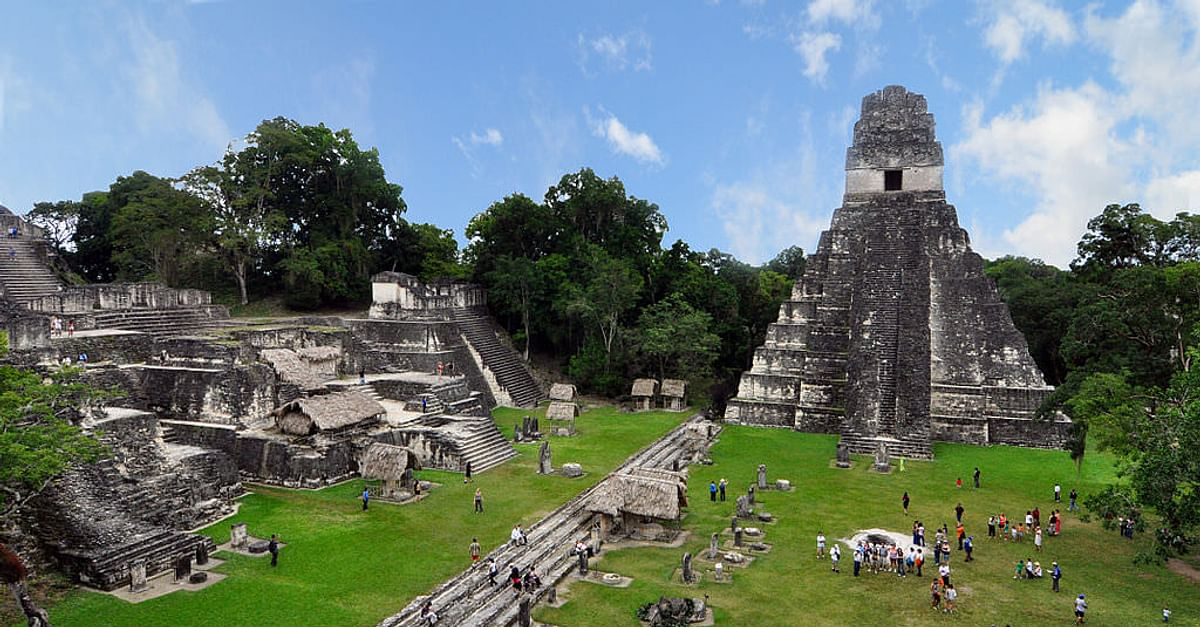Can you describe the significance of this archaeological site? Tikal is one of the most significant archaeological sites of the ancient Maya civilization, located in modern-day Guatemala. The site flourished between the 6th century BCE and the 10th century CE, becoming a major center for cultural, political, and military activities. The towering pyramid-like temples, including Temple I (the Temple of the Great Jaguar), served religious and ceremonial purposes and were often used as tombs for rulers. The complex demonstrates the advanced engineering, architectural skill, and astronomical knowledge of the Maya. Today, Tikal is recognized as a UNESCO World Heritage Site, attracting archaeologists, historians, and tourists from around the world. What kind of wildlife might be found around this temple complex? The lush forests surrounding the Tikal temple complex are home to a diverse array of wildlife. Visitors might spot howler monkeys, spider monkeys, and a variety of bird species, including toucans and parakeets. Occasionally, jaguars and other wild cats can be found in the area, though they are more elusive. The dense jungle also houses many different species of insects, reptiles, and amphibians, contributing to the rich biodiversity of the region. 